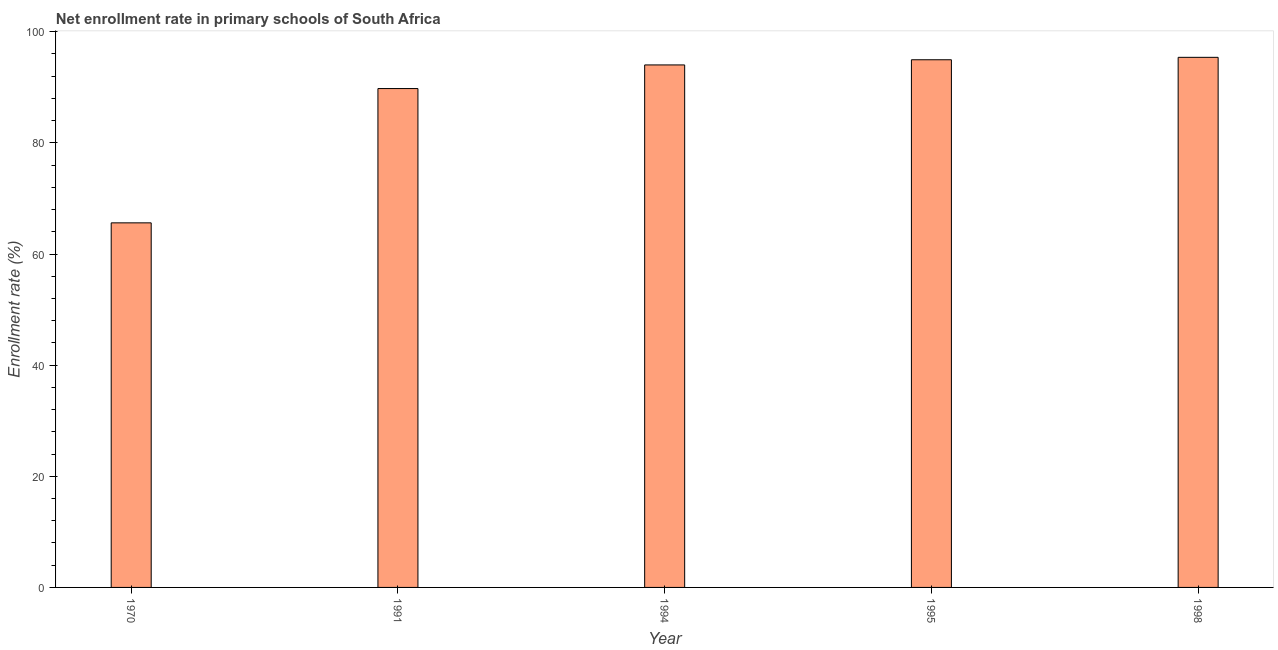Does the graph contain any zero values?
Your answer should be very brief. No. Does the graph contain grids?
Your answer should be very brief. No. What is the title of the graph?
Your answer should be very brief. Net enrollment rate in primary schools of South Africa. What is the label or title of the Y-axis?
Offer a very short reply. Enrollment rate (%). What is the net enrollment rate in primary schools in 1970?
Offer a very short reply. 65.61. Across all years, what is the maximum net enrollment rate in primary schools?
Keep it short and to the point. 95.4. Across all years, what is the minimum net enrollment rate in primary schools?
Offer a very short reply. 65.61. In which year was the net enrollment rate in primary schools maximum?
Ensure brevity in your answer.  1998. What is the sum of the net enrollment rate in primary schools?
Your answer should be very brief. 439.78. What is the difference between the net enrollment rate in primary schools in 1991 and 1998?
Give a very brief answer. -5.62. What is the average net enrollment rate in primary schools per year?
Make the answer very short. 87.96. What is the median net enrollment rate in primary schools?
Your answer should be compact. 94.03. What is the difference between the highest and the second highest net enrollment rate in primary schools?
Ensure brevity in your answer.  0.44. Is the sum of the net enrollment rate in primary schools in 1994 and 1995 greater than the maximum net enrollment rate in primary schools across all years?
Provide a succinct answer. Yes. What is the difference between the highest and the lowest net enrollment rate in primary schools?
Offer a very short reply. 29.79. Are all the bars in the graph horizontal?
Ensure brevity in your answer.  No. How many years are there in the graph?
Make the answer very short. 5. What is the Enrollment rate (%) of 1970?
Ensure brevity in your answer.  65.61. What is the Enrollment rate (%) of 1991?
Provide a short and direct response. 89.78. What is the Enrollment rate (%) in 1994?
Keep it short and to the point. 94.03. What is the Enrollment rate (%) in 1995?
Ensure brevity in your answer.  94.96. What is the Enrollment rate (%) in 1998?
Offer a very short reply. 95.4. What is the difference between the Enrollment rate (%) in 1970 and 1991?
Provide a short and direct response. -24.17. What is the difference between the Enrollment rate (%) in 1970 and 1994?
Make the answer very short. -28.42. What is the difference between the Enrollment rate (%) in 1970 and 1995?
Your response must be concise. -29.35. What is the difference between the Enrollment rate (%) in 1970 and 1998?
Your response must be concise. -29.79. What is the difference between the Enrollment rate (%) in 1991 and 1994?
Provide a succinct answer. -4.25. What is the difference between the Enrollment rate (%) in 1991 and 1995?
Make the answer very short. -5.18. What is the difference between the Enrollment rate (%) in 1991 and 1998?
Your response must be concise. -5.62. What is the difference between the Enrollment rate (%) in 1994 and 1995?
Provide a short and direct response. -0.93. What is the difference between the Enrollment rate (%) in 1994 and 1998?
Offer a very short reply. -1.37. What is the difference between the Enrollment rate (%) in 1995 and 1998?
Provide a short and direct response. -0.44. What is the ratio of the Enrollment rate (%) in 1970 to that in 1991?
Your answer should be very brief. 0.73. What is the ratio of the Enrollment rate (%) in 1970 to that in 1994?
Offer a terse response. 0.7. What is the ratio of the Enrollment rate (%) in 1970 to that in 1995?
Offer a terse response. 0.69. What is the ratio of the Enrollment rate (%) in 1970 to that in 1998?
Make the answer very short. 0.69. What is the ratio of the Enrollment rate (%) in 1991 to that in 1994?
Make the answer very short. 0.95. What is the ratio of the Enrollment rate (%) in 1991 to that in 1995?
Provide a short and direct response. 0.94. What is the ratio of the Enrollment rate (%) in 1991 to that in 1998?
Ensure brevity in your answer.  0.94. What is the ratio of the Enrollment rate (%) in 1995 to that in 1998?
Your answer should be compact. 0.99. 